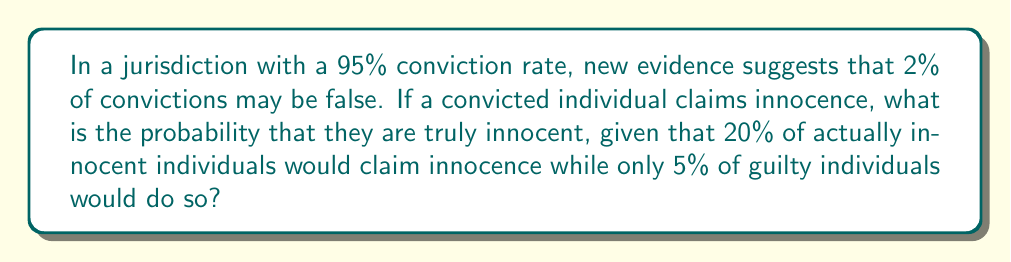What is the answer to this math problem? To solve this problem, we'll use Bayesian inference. Let's define our events:

A: The individual is actually innocent
B: The individual claims innocence

We're given the following probabilities:

P(A) = 0.02 (probability of false conviction)
P(B|A) = 0.20 (probability an innocent person claims innocence)
P(B|not A) = 0.05 (probability a guilty person claims innocence)

We want to find P(A|B), the probability of innocence given a claim of innocence.

Using Bayes' theorem:

$$ P(A|B) = \frac{P(B|A) \cdot P(A)}{P(B)} $$

We need to calculate P(B) using the law of total probability:

$$ P(B) = P(B|A) \cdot P(A) + P(B|\text{not }A) \cdot P(\text{not }A) $$

$$ P(B) = 0.20 \cdot 0.02 + 0.05 \cdot 0.98 = 0.004 + 0.049 = 0.053 $$

Now we can plug this into Bayes' theorem:

$$ P(A|B) = \frac{0.20 \cdot 0.02}{0.053} \approx 0.0755 $$

Converting to a percentage:

$$ 0.0755 \cdot 100\% \approx 7.55\% $$
Answer: The probability that a convicted individual claiming innocence is truly innocent is approximately 7.55%. 